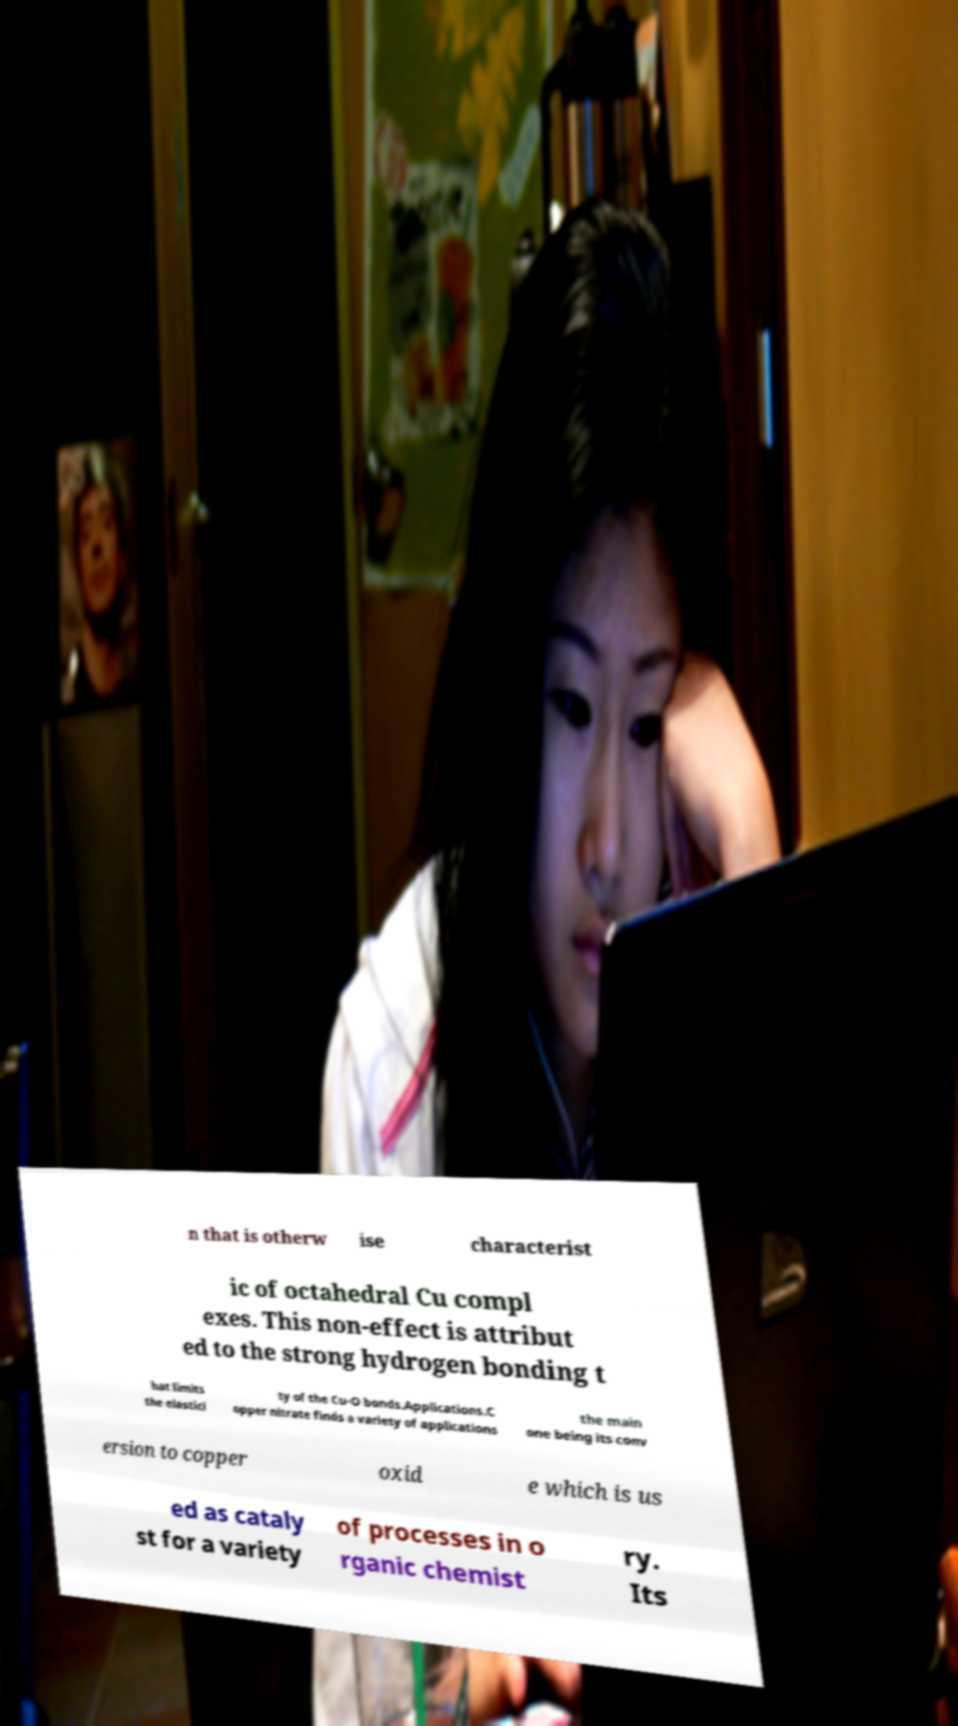Could you extract and type out the text from this image? n that is otherw ise characterist ic of octahedral Cu compl exes. This non-effect is attribut ed to the strong hydrogen bonding t hat limits the elastici ty of the Cu-O bonds.Applications.C opper nitrate finds a variety of applications the main one being its conv ersion to copper oxid e which is us ed as cataly st for a variety of processes in o rganic chemist ry. Its 